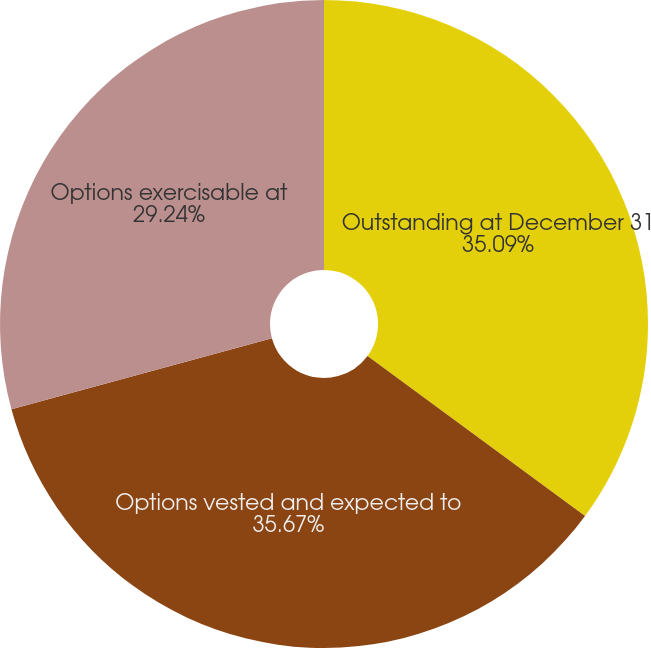Convert chart to OTSL. <chart><loc_0><loc_0><loc_500><loc_500><pie_chart><fcel>Outstanding at December 31<fcel>Options vested and expected to<fcel>Options exercisable at<nl><fcel>35.09%<fcel>35.67%<fcel>29.24%<nl></chart> 